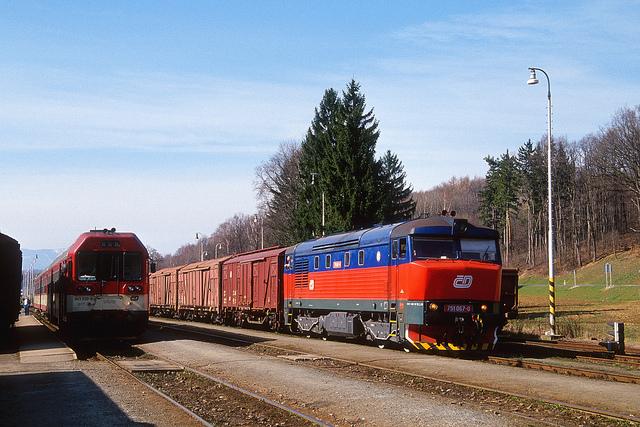What season is it?
Give a very brief answer. Fall. How many trains are there?
Write a very short answer. 2. What kind of train is that?
Short answer required. Freight. What time of day is it?
Quick response, please. Afternoon. 